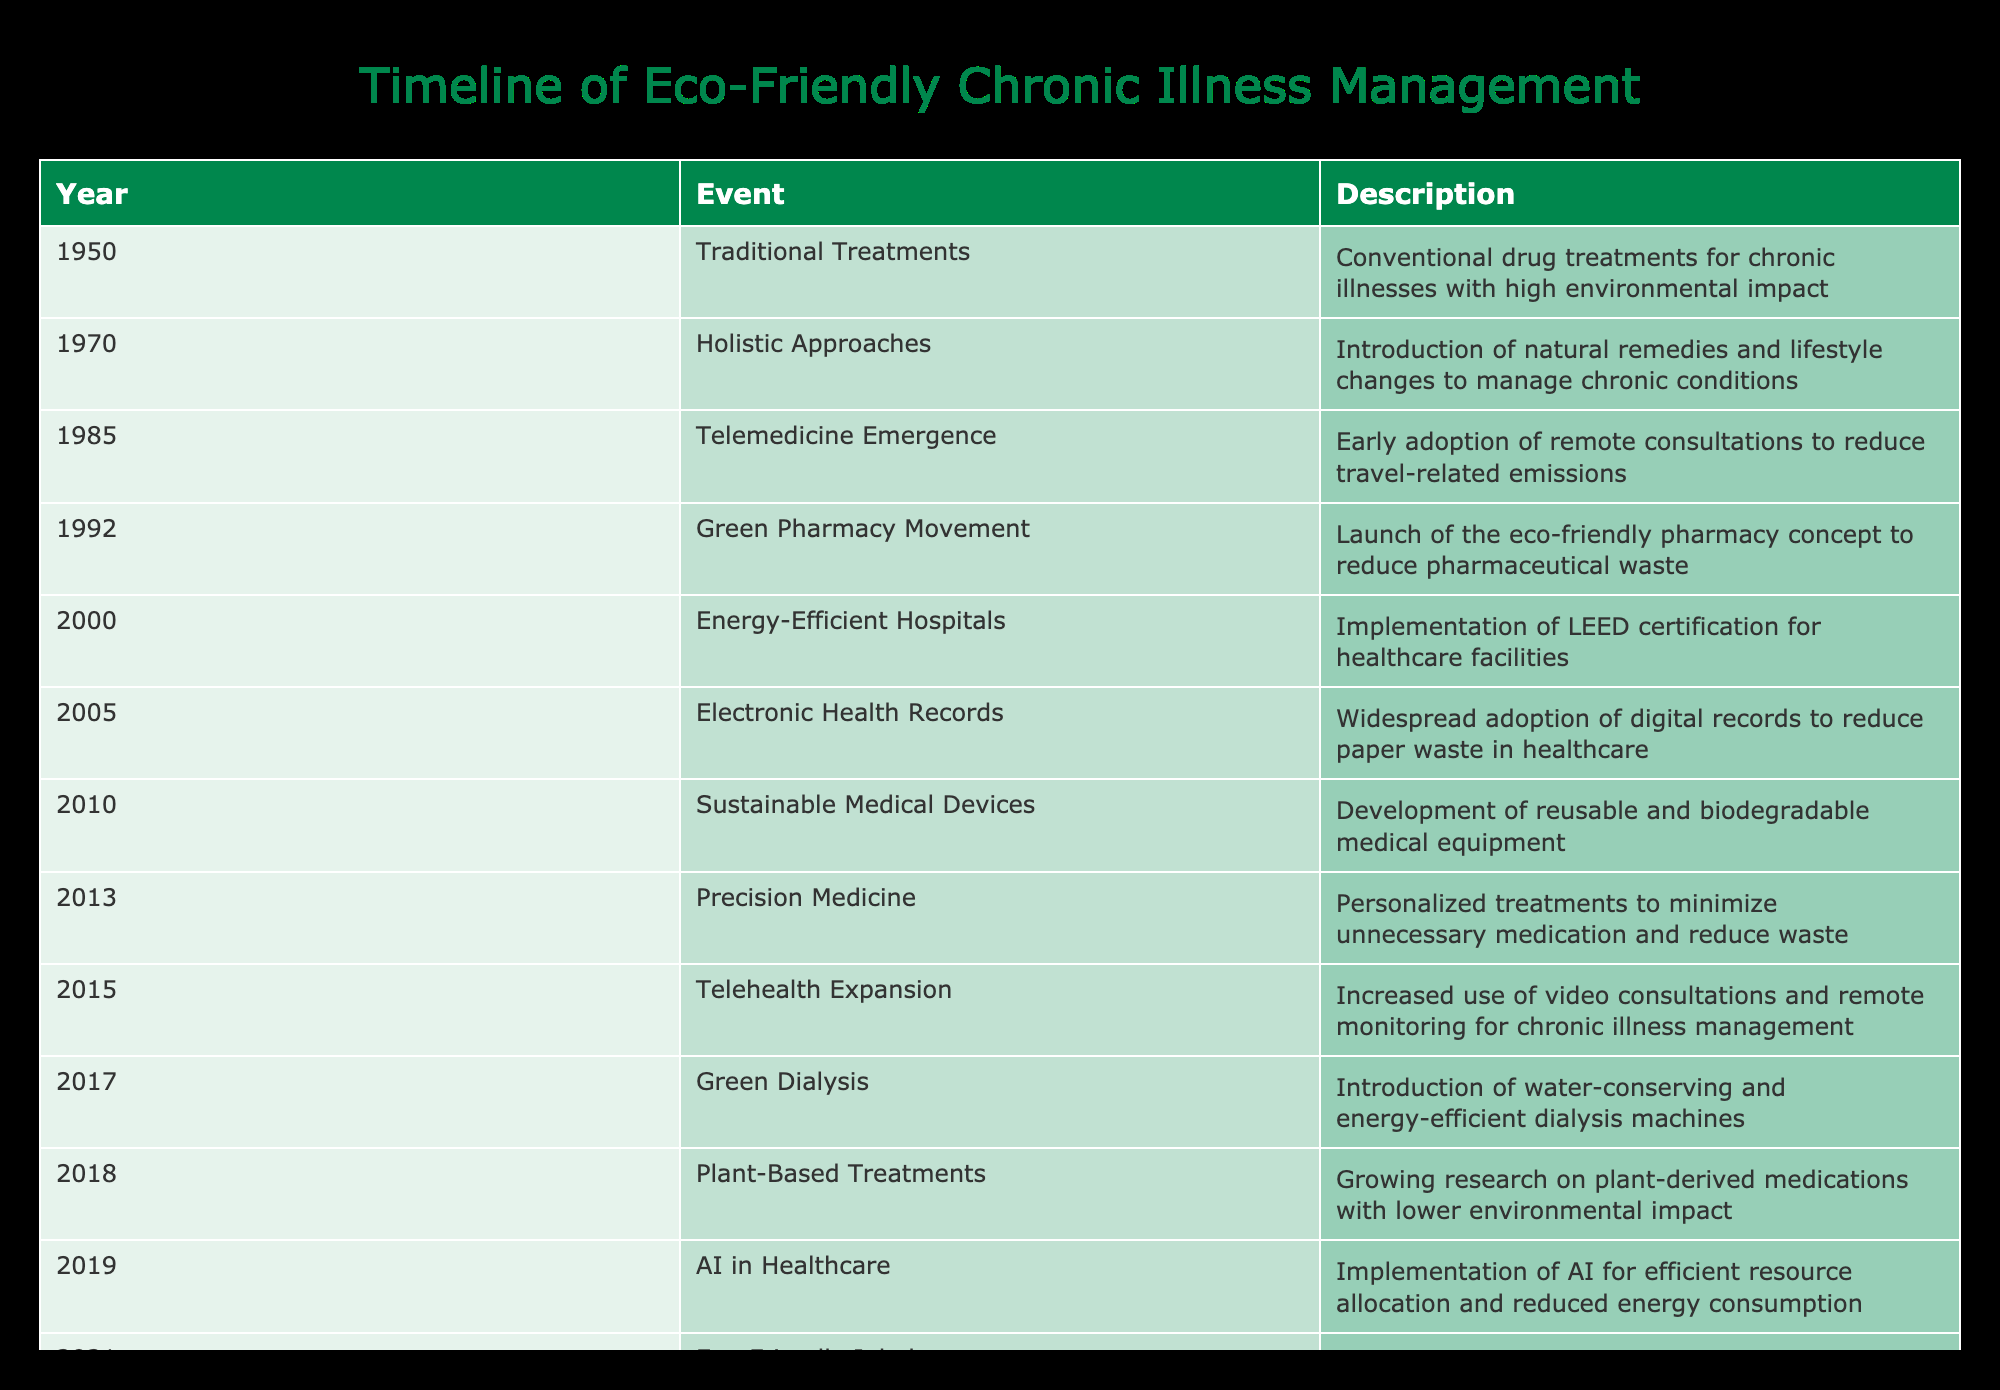What year did the Green Pharmacy Movement start? Referring to the table, the Green Pharmacy Movement is listed under the year 1992.
Answer: 1992 What is the description of the event in 2010? According to the table, in 2010, the description provided is the development of sustainable medical devices, referring to reusable and biodegradable medical equipment.
Answer: Development of reusable and biodegradable medical equipment How many years passed between the introduction of Telemedicine and the adoption of Electronic Health Records? The introduction of Telemedicine was in 1985 and Electronic Health Records were adopted in 2005. The difference in years is 2005 - 1985 = 20 years.
Answer: 20 years Is the Plant-Based Treatments event associated with lower environmental impact? The table specifies that Plant-Based Treatments involve growing research on plant-derived medications with lower environmental impact, which confirms a yes.
Answer: Yes Which event occurred first: Eco-Friendly Inhalers or Circular Economy in Healthcare? The event Eco-Friendly Inhalers occurred in 2021, while Circular Economy in Healthcare occurred in 2022. Since 2021 comes before 2022, Eco-Friendly Inhalers occurred first.
Answer: Eco-Friendly Inhalers How many events focused on healthcare technology and management strategies from 2005 onward? From the table, counting the events from 2005, we find Electronic Health Records, Sustainable Medical Devices, Telehealth Expansion, AI in Healthcare, Eco-Friendly Inhalers, and Circular Economy in Healthcare, totaling 6 events.
Answer: 6 events What percentage of the events listed until 2018 pertain to eco-friendly solutions? Up until 2018, there are 10 events listed. The eco-friendly events are Green Pharmacy Movement, Energy-Efficient Hospitals, Sustainable Medical Devices, Green Dialysis, and Plant-Based Treatments, totaling 5. Therefore, the percentage is (5/10)*100 = 50%.
Answer: 50% In what context was Precision Medicine mentioned? The table indicates that Precision Medicine was introduced in 2013, and it consists of personalized treatments to minimize unnecessary medication and reduce waste.
Answer: Personalized treatments to minimize unnecessary medication and reduce waste What are the future projections for chronic illness management mentioned in the timeline? The timeline includes projections such as Green Chemotherapy in 2024 and Regenerative Health Centers in 2025, which suggest advancements focused on environmental healing.
Answer: Green Chemotherapy and Regenerative Health Centers 